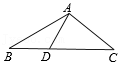If in triangle ABC, the lengths of AB and AC are equal, and D lies on the perpendicular bisector of AB, and angle ADC is 80 degrees, what is the measure of angle C? In triangle ABC with AB and AC being equally long, point D on the perpendicular bisector of AB suggests triangle ABD is isosceles with AD and BD being equal. In an isosceles triangle, angles opposite the equal sides are also equal. Thus, angle BAD is 50 degrees because angles in a triangle sum up to 180 degrees, and angle ADC provides a constraint that angle B is 50 degrees as the remaining part of the linear pair with angle ADC. Consequently, in triangle ABC, both angle B and angle C are 40 degrees each, since it is also isosceles and the sum of angles in a triangle is always 180 degrees. In a more intuitive sense, it’s like cutting a pie into three slices, where two slices are equal in size, and you know the combined size of the two equal slices; you can easily deduct the size of the third slice. Hence, the measure of angle C is indeed 40 degrees. 